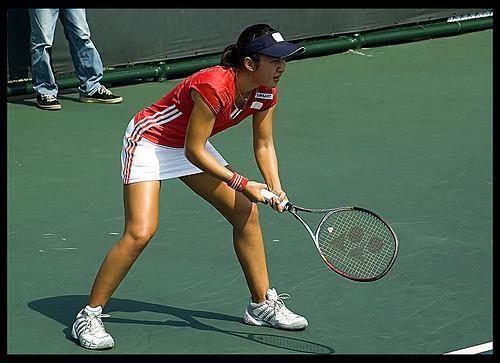How many people can be seen?
Give a very brief answer. 2. 